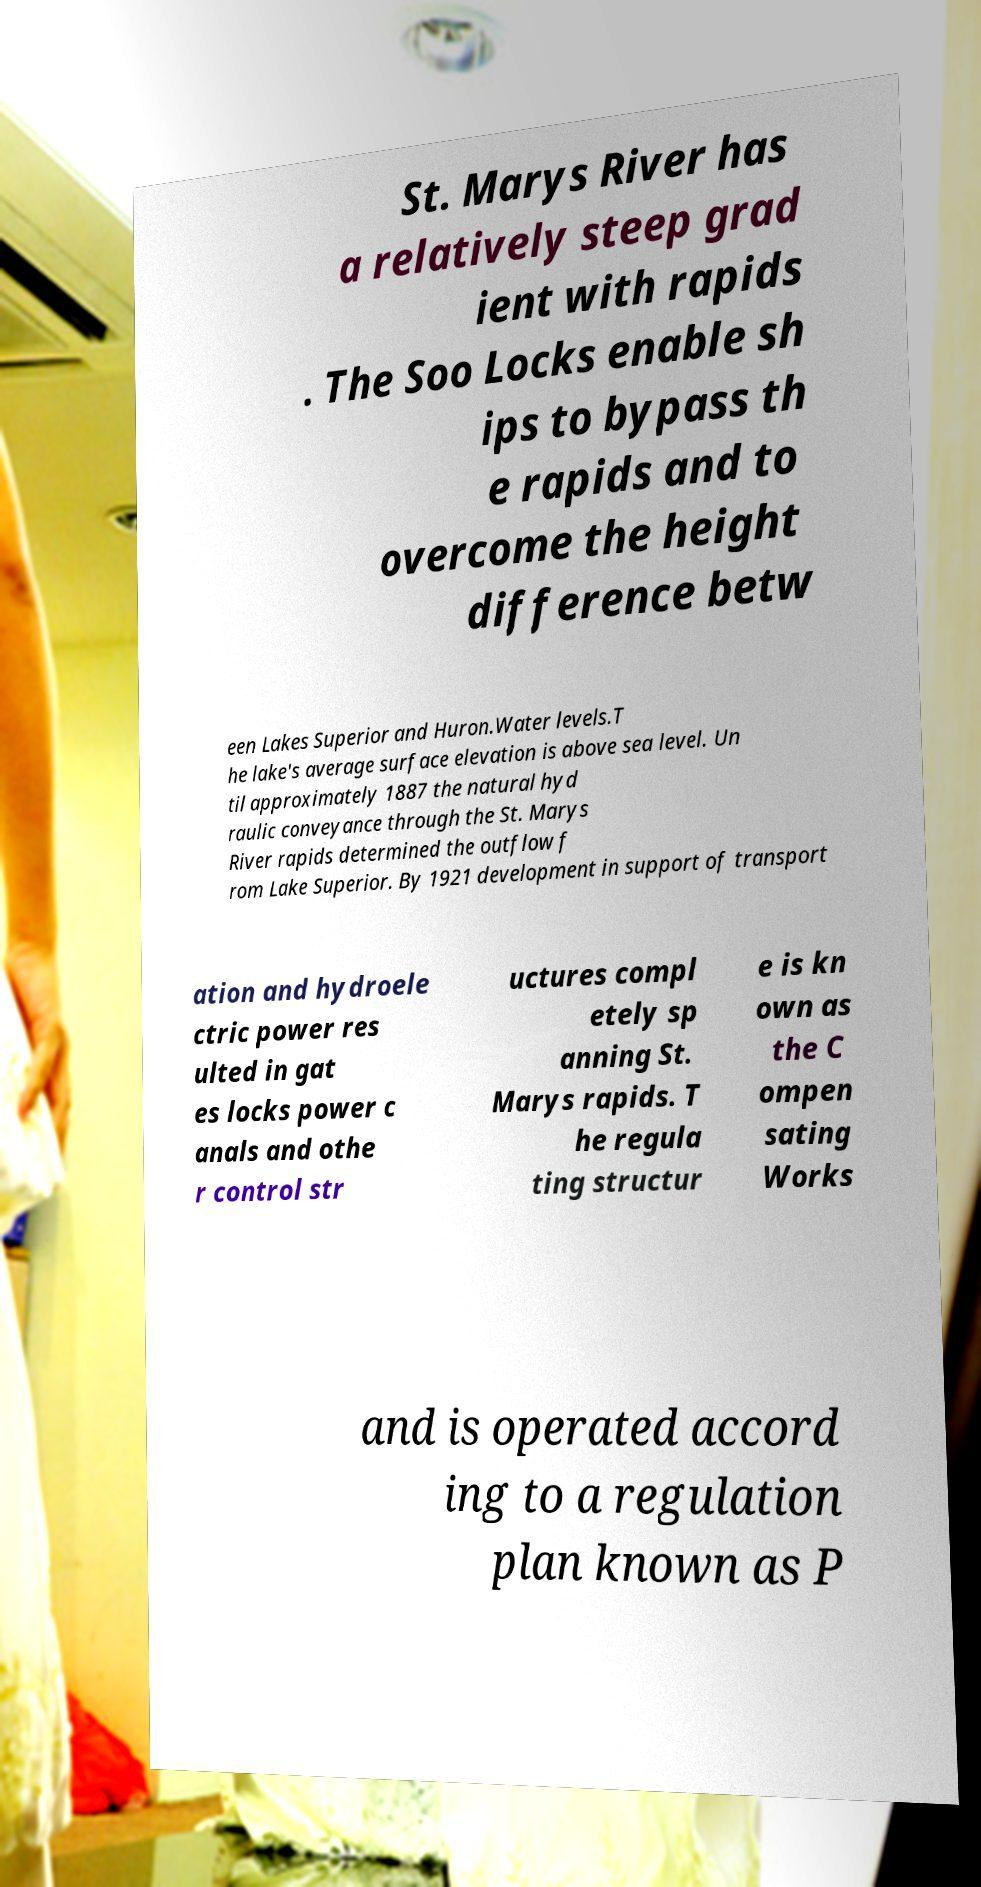I need the written content from this picture converted into text. Can you do that? St. Marys River has a relatively steep grad ient with rapids . The Soo Locks enable sh ips to bypass th e rapids and to overcome the height difference betw een Lakes Superior and Huron.Water levels.T he lake's average surface elevation is above sea level. Un til approximately 1887 the natural hyd raulic conveyance through the St. Marys River rapids determined the outflow f rom Lake Superior. By 1921 development in support of transport ation and hydroele ctric power res ulted in gat es locks power c anals and othe r control str uctures compl etely sp anning St. Marys rapids. T he regula ting structur e is kn own as the C ompen sating Works and is operated accord ing to a regulation plan known as P 